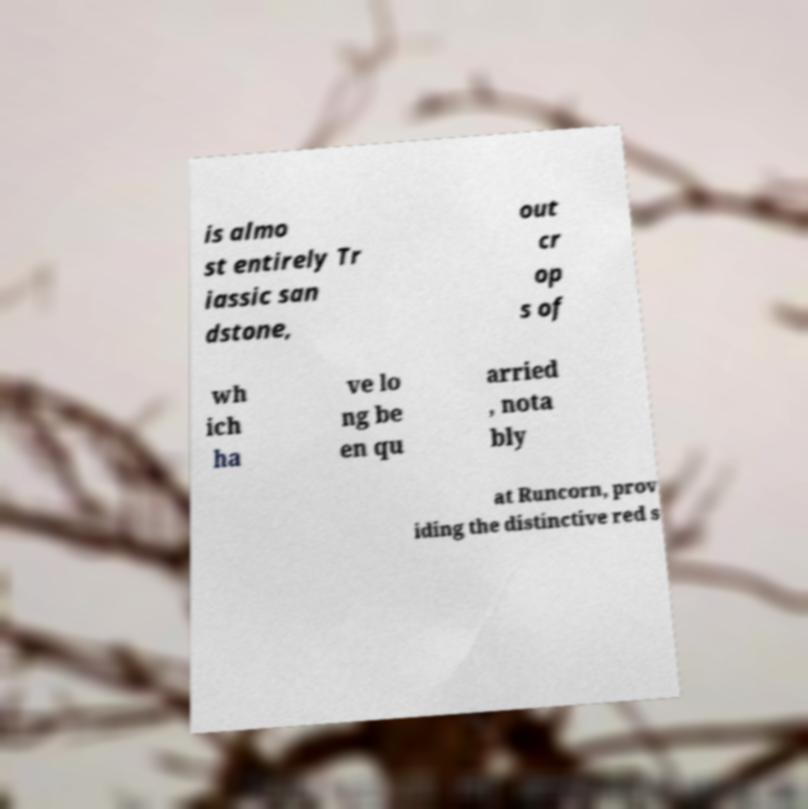What messages or text are displayed in this image? I need them in a readable, typed format. is almo st entirely Tr iassic san dstone, out cr op s of wh ich ha ve lo ng be en qu arried , nota bly at Runcorn, prov iding the distinctive red s 